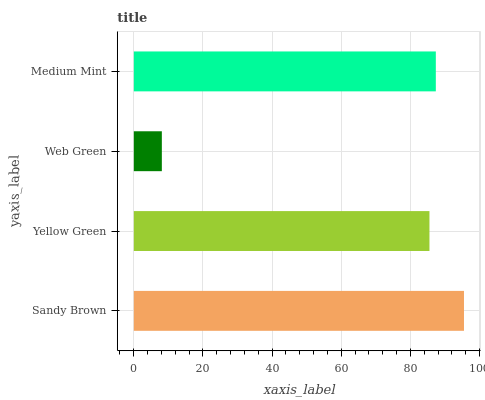Is Web Green the minimum?
Answer yes or no. Yes. Is Sandy Brown the maximum?
Answer yes or no. Yes. Is Yellow Green the minimum?
Answer yes or no. No. Is Yellow Green the maximum?
Answer yes or no. No. Is Sandy Brown greater than Yellow Green?
Answer yes or no. Yes. Is Yellow Green less than Sandy Brown?
Answer yes or no. Yes. Is Yellow Green greater than Sandy Brown?
Answer yes or no. No. Is Sandy Brown less than Yellow Green?
Answer yes or no. No. Is Medium Mint the high median?
Answer yes or no. Yes. Is Yellow Green the low median?
Answer yes or no. Yes. Is Sandy Brown the high median?
Answer yes or no. No. Is Web Green the low median?
Answer yes or no. No. 